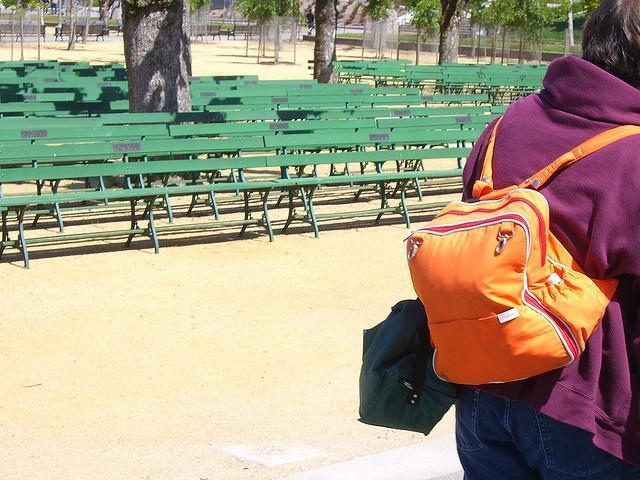How many backpacks are there?
Give a very brief answer. 1. How many benches are visible?
Give a very brief answer. 5. How many handbags are there?
Give a very brief answer. 1. How many people are there?
Give a very brief answer. 1. 